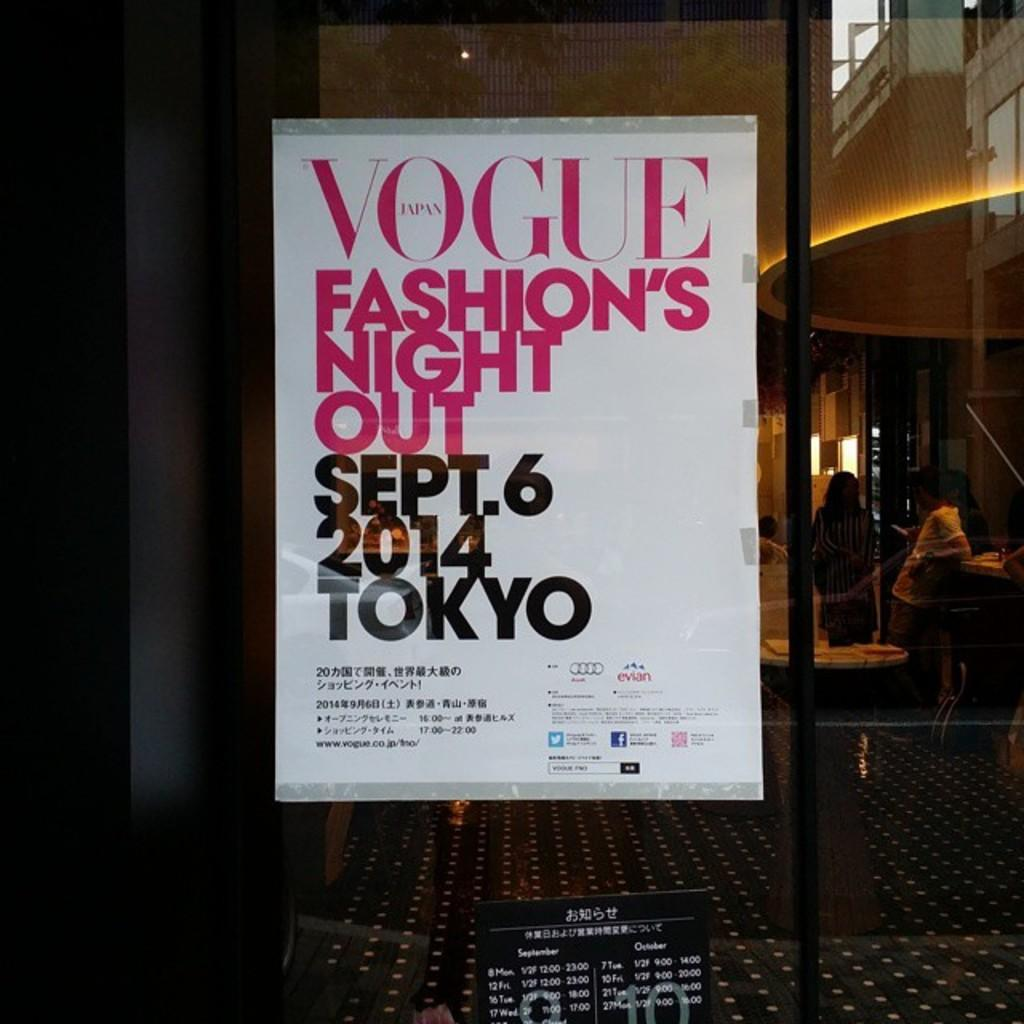Provide a one-sentence caption for the provided image. A poster advertises a fashion event sponsored by Vogue. 